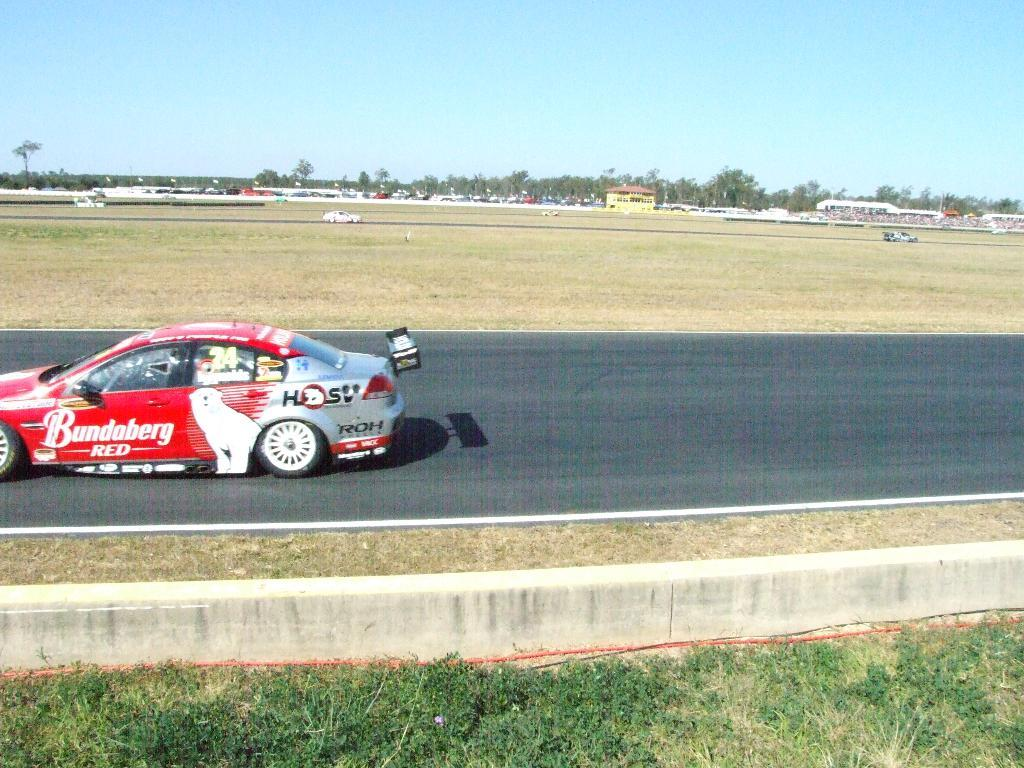What color is the car in the image? The car in the image is red. What is the car doing in the image? The car is moving in the image. Where is the car located in the image? The car is on the left side of the image. What type of terrain is visible at the bottom of the image? There is grass at the bottom of the image. What is visible at the top of the image? The sky is visible at the top of the image. Can you see any leaves falling from the trees in the image? There are no trees visible in the image, so it is not possible to see any leaves falling. 